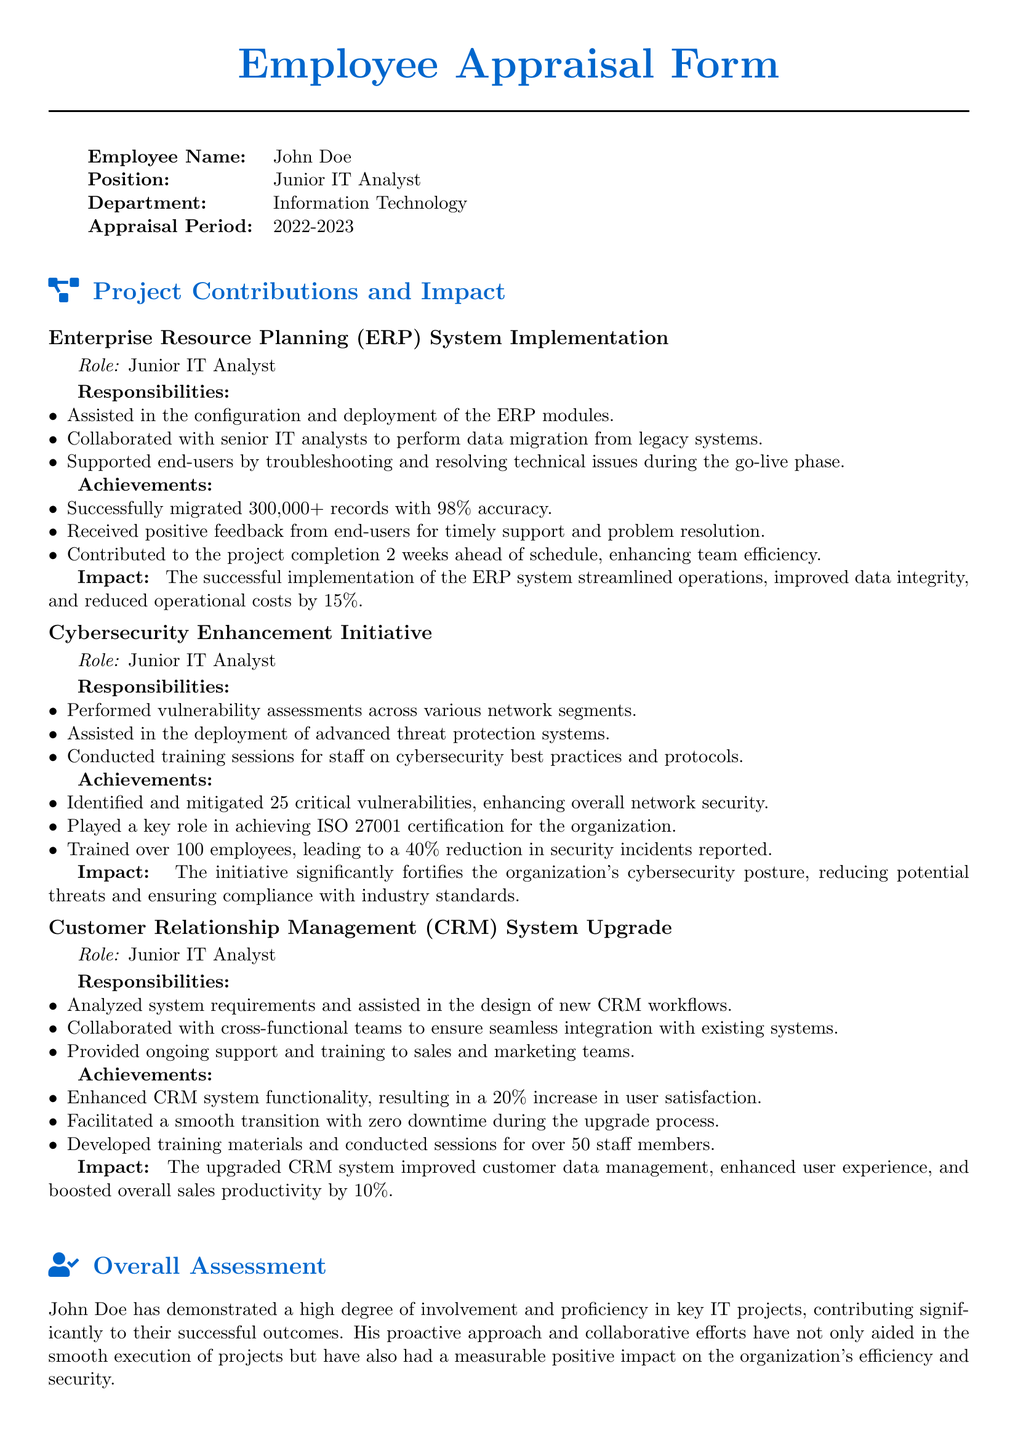what is the employee name? The document clearly states the employee's name at the beginning, which is John Doe.
Answer: John Doe what was the appraisal period? The appraisal period is mentioned in the table under "Appraisal Period," which is 2022-2023.
Answer: 2022-2023 how many records were migrated during the ERP implementation? The ERP system implementation section specifies that 300,000+ records were migrated successfully.
Answer: 300,000+ what role did John Doe have in the cybersecurity initiative? The document indicates John Doe's role as Junior IT Analyst in the cybersecurity enhancement initiative.
Answer: Junior IT Analyst what percentage reduction in security incidents was achieved through training? The document states that training led to a 40% reduction in reported security incidents.
Answer: 40% what certification did John Doe help achieve? The cybersecurity section notes that the organization achieved ISO 27001 certification due to John Doe's contributions.
Answer: ISO 27001 how many employees received training for the CRM system upgrade? The document mentions that training sessions were conducted for over 50 staff members during the CRM upgrade.
Answer: over 50 what was the impact of the ERP system implementation? The impact section of the ERP implementation states that it streamlined operations and reduced operational costs by 15%.
Answer: reduced operational costs by 15% what overall assessment is given for John Doe's performance? The overall assessment section summarizes that John Doe has demonstrated high involvement and proficiency in key IT projects.
Answer: high degree of involvement and proficiency 